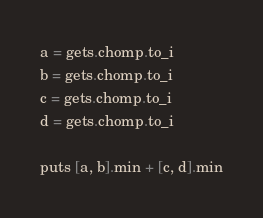<code> <loc_0><loc_0><loc_500><loc_500><_Ruby_>a = gets.chomp.to_i
b = gets.chomp.to_i
c = gets.chomp.to_i
d = gets.chomp.to_i

puts [a, b].min + [c, d].min</code> 